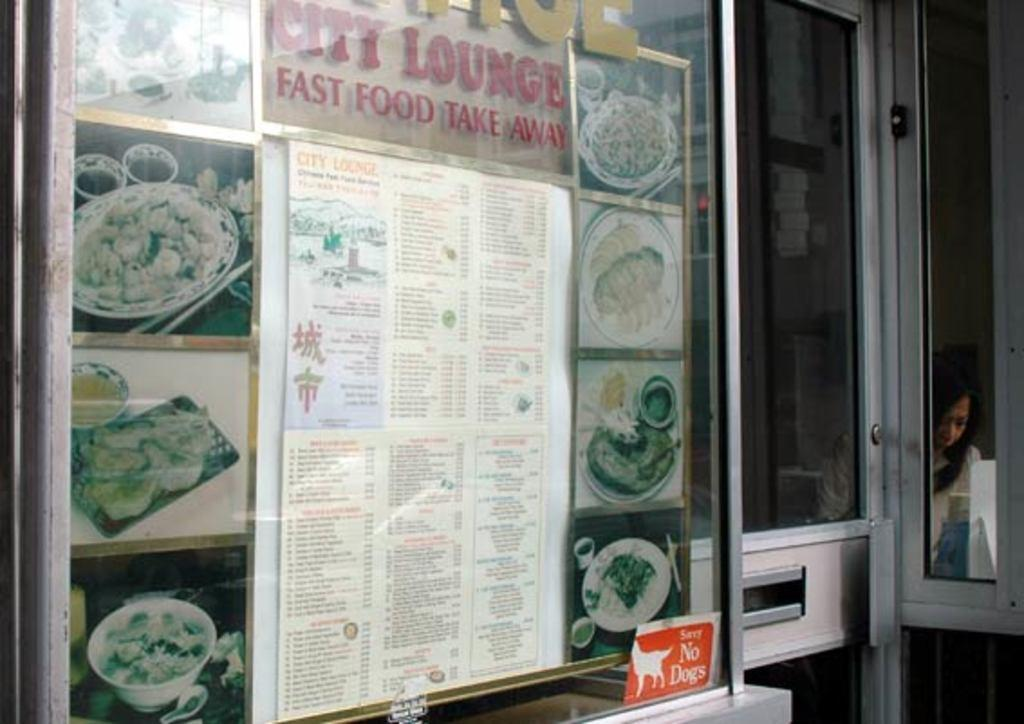Provide a one-sentence caption for the provided image. City lounge fast food take away menu showing in restaurant. 